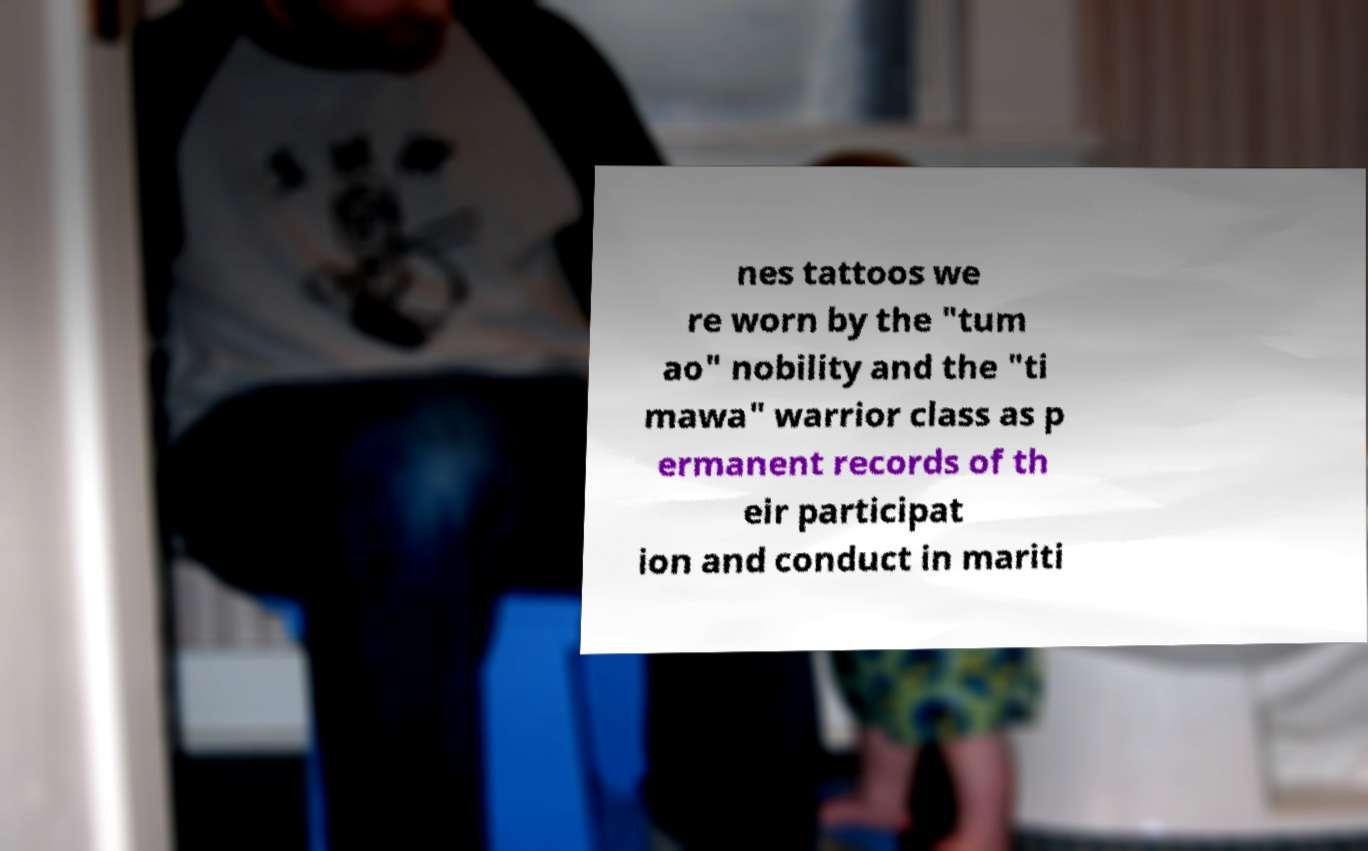There's text embedded in this image that I need extracted. Can you transcribe it verbatim? nes tattoos we re worn by the "tum ao" nobility and the "ti mawa" warrior class as p ermanent records of th eir participat ion and conduct in mariti 